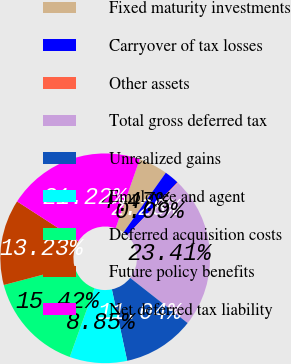<chart> <loc_0><loc_0><loc_500><loc_500><pie_chart><fcel>Fixed maturity investments<fcel>Carryover of tax losses<fcel>Other assets<fcel>Total gross deferred tax<fcel>Unrealized gains<fcel>Employee and agent<fcel>Deferred acquisition costs<fcel>Future policy benefits<fcel>Net deferred tax liability<nl><fcel>4.47%<fcel>2.28%<fcel>0.09%<fcel>23.42%<fcel>11.04%<fcel>8.85%<fcel>15.42%<fcel>13.23%<fcel>21.23%<nl></chart> 